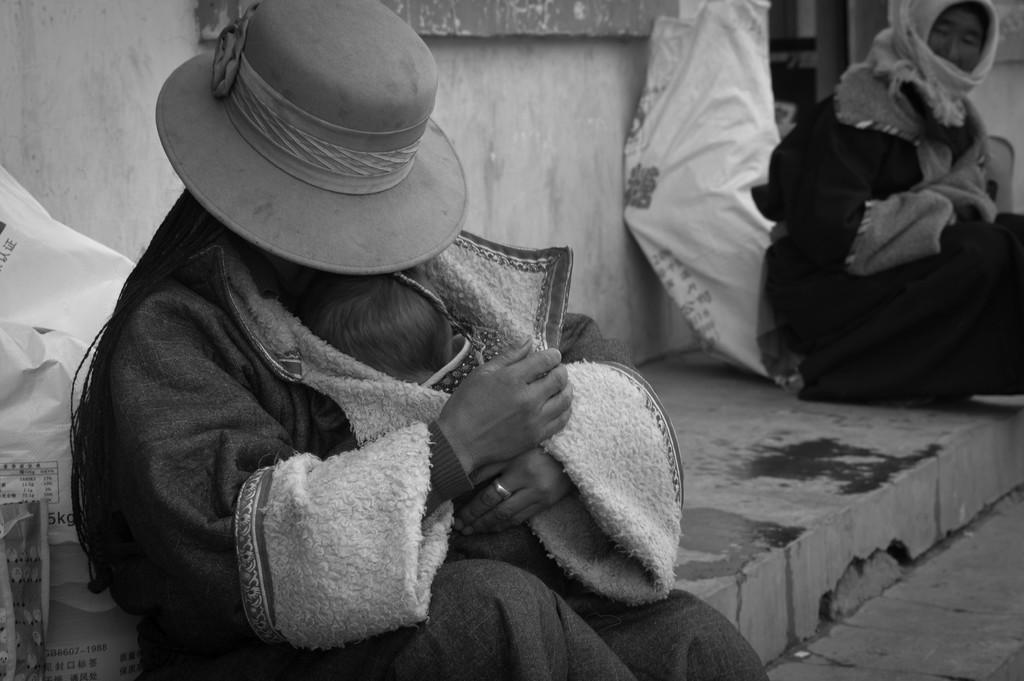Please provide a concise description of this image. In this black and white image there are two persons sitting on the pavement of a road, one of them is holding a baby in his hand. Behind them there are few objects placed and there is a wall. 